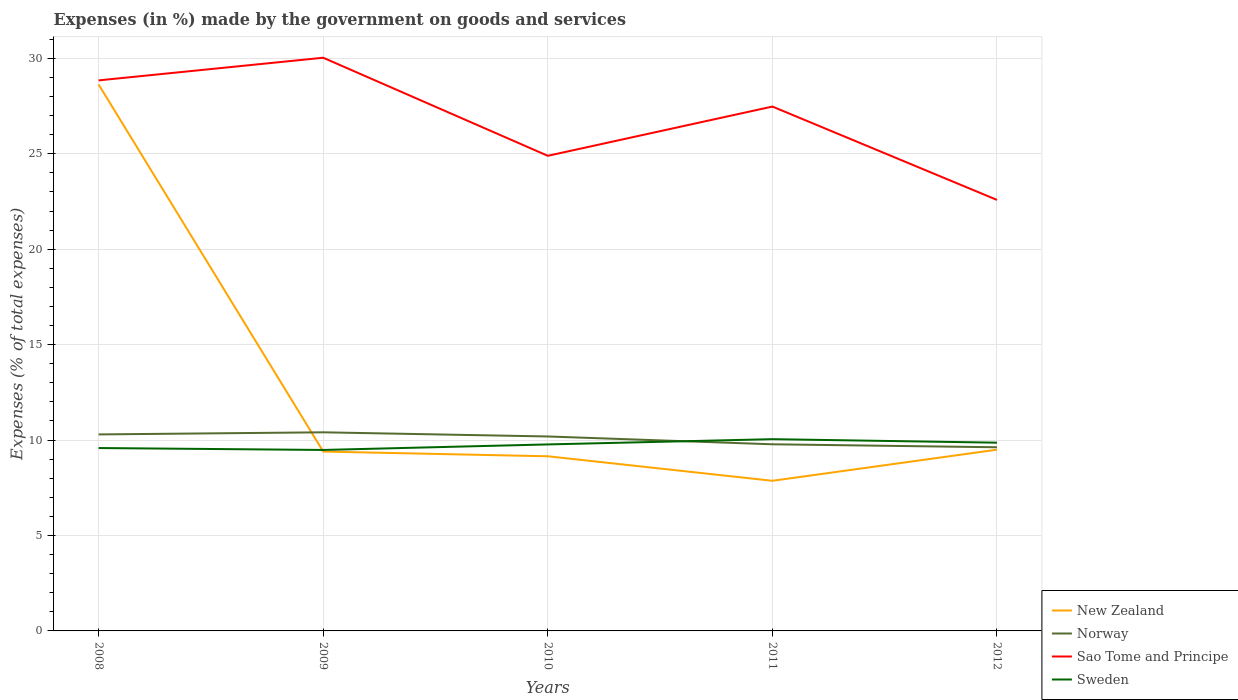Does the line corresponding to Norway intersect with the line corresponding to New Zealand?
Your answer should be very brief. Yes. Is the number of lines equal to the number of legend labels?
Your answer should be compact. Yes. Across all years, what is the maximum percentage of expenses made by the government on goods and services in Sweden?
Offer a terse response. 9.48. What is the total percentage of expenses made by the government on goods and services in New Zealand in the graph?
Offer a very short reply. 1.28. What is the difference between the highest and the second highest percentage of expenses made by the government on goods and services in Sweden?
Ensure brevity in your answer.  0.57. What is the difference between the highest and the lowest percentage of expenses made by the government on goods and services in Norway?
Make the answer very short. 3. How many lines are there?
Your answer should be compact. 4. Does the graph contain any zero values?
Provide a short and direct response. No. How many legend labels are there?
Provide a short and direct response. 4. What is the title of the graph?
Your answer should be very brief. Expenses (in %) made by the government on goods and services. Does "Tajikistan" appear as one of the legend labels in the graph?
Provide a short and direct response. No. What is the label or title of the Y-axis?
Your answer should be compact. Expenses (% of total expenses). What is the Expenses (% of total expenses) of New Zealand in 2008?
Your answer should be very brief. 28.63. What is the Expenses (% of total expenses) of Norway in 2008?
Provide a succinct answer. 10.3. What is the Expenses (% of total expenses) of Sao Tome and Principe in 2008?
Keep it short and to the point. 28.85. What is the Expenses (% of total expenses) in Sweden in 2008?
Offer a very short reply. 9.58. What is the Expenses (% of total expenses) of New Zealand in 2009?
Ensure brevity in your answer.  9.4. What is the Expenses (% of total expenses) of Norway in 2009?
Make the answer very short. 10.41. What is the Expenses (% of total expenses) in Sao Tome and Principe in 2009?
Your response must be concise. 30.03. What is the Expenses (% of total expenses) in Sweden in 2009?
Give a very brief answer. 9.48. What is the Expenses (% of total expenses) of New Zealand in 2010?
Provide a succinct answer. 9.15. What is the Expenses (% of total expenses) in Norway in 2010?
Provide a short and direct response. 10.19. What is the Expenses (% of total expenses) of Sao Tome and Principe in 2010?
Make the answer very short. 24.89. What is the Expenses (% of total expenses) in Sweden in 2010?
Offer a very short reply. 9.77. What is the Expenses (% of total expenses) of New Zealand in 2011?
Ensure brevity in your answer.  7.87. What is the Expenses (% of total expenses) of Norway in 2011?
Offer a terse response. 9.78. What is the Expenses (% of total expenses) in Sao Tome and Principe in 2011?
Offer a terse response. 27.47. What is the Expenses (% of total expenses) in Sweden in 2011?
Offer a very short reply. 10.05. What is the Expenses (% of total expenses) in New Zealand in 2012?
Offer a very short reply. 9.5. What is the Expenses (% of total expenses) in Norway in 2012?
Your answer should be very brief. 9.62. What is the Expenses (% of total expenses) in Sao Tome and Principe in 2012?
Make the answer very short. 22.58. What is the Expenses (% of total expenses) in Sweden in 2012?
Your response must be concise. 9.86. Across all years, what is the maximum Expenses (% of total expenses) in New Zealand?
Provide a succinct answer. 28.63. Across all years, what is the maximum Expenses (% of total expenses) of Norway?
Your answer should be very brief. 10.41. Across all years, what is the maximum Expenses (% of total expenses) in Sao Tome and Principe?
Ensure brevity in your answer.  30.03. Across all years, what is the maximum Expenses (% of total expenses) in Sweden?
Keep it short and to the point. 10.05. Across all years, what is the minimum Expenses (% of total expenses) of New Zealand?
Keep it short and to the point. 7.87. Across all years, what is the minimum Expenses (% of total expenses) of Norway?
Make the answer very short. 9.62. Across all years, what is the minimum Expenses (% of total expenses) in Sao Tome and Principe?
Give a very brief answer. 22.58. Across all years, what is the minimum Expenses (% of total expenses) of Sweden?
Your answer should be very brief. 9.48. What is the total Expenses (% of total expenses) in New Zealand in the graph?
Your answer should be compact. 64.54. What is the total Expenses (% of total expenses) in Norway in the graph?
Ensure brevity in your answer.  50.29. What is the total Expenses (% of total expenses) in Sao Tome and Principe in the graph?
Your answer should be compact. 133.83. What is the total Expenses (% of total expenses) in Sweden in the graph?
Provide a short and direct response. 48.75. What is the difference between the Expenses (% of total expenses) of New Zealand in 2008 and that in 2009?
Provide a short and direct response. 19.23. What is the difference between the Expenses (% of total expenses) in Norway in 2008 and that in 2009?
Keep it short and to the point. -0.11. What is the difference between the Expenses (% of total expenses) of Sao Tome and Principe in 2008 and that in 2009?
Offer a terse response. -1.19. What is the difference between the Expenses (% of total expenses) of Sweden in 2008 and that in 2009?
Give a very brief answer. 0.1. What is the difference between the Expenses (% of total expenses) in New Zealand in 2008 and that in 2010?
Your answer should be compact. 19.48. What is the difference between the Expenses (% of total expenses) in Norway in 2008 and that in 2010?
Give a very brief answer. 0.11. What is the difference between the Expenses (% of total expenses) in Sao Tome and Principe in 2008 and that in 2010?
Your answer should be compact. 3.95. What is the difference between the Expenses (% of total expenses) of Sweden in 2008 and that in 2010?
Your response must be concise. -0.19. What is the difference between the Expenses (% of total expenses) of New Zealand in 2008 and that in 2011?
Keep it short and to the point. 20.76. What is the difference between the Expenses (% of total expenses) in Norway in 2008 and that in 2011?
Ensure brevity in your answer.  0.52. What is the difference between the Expenses (% of total expenses) of Sao Tome and Principe in 2008 and that in 2011?
Ensure brevity in your answer.  1.37. What is the difference between the Expenses (% of total expenses) in Sweden in 2008 and that in 2011?
Your answer should be compact. -0.46. What is the difference between the Expenses (% of total expenses) in New Zealand in 2008 and that in 2012?
Keep it short and to the point. 19.13. What is the difference between the Expenses (% of total expenses) in Norway in 2008 and that in 2012?
Provide a short and direct response. 0.67. What is the difference between the Expenses (% of total expenses) in Sao Tome and Principe in 2008 and that in 2012?
Provide a succinct answer. 6.26. What is the difference between the Expenses (% of total expenses) of Sweden in 2008 and that in 2012?
Provide a short and direct response. -0.28. What is the difference between the Expenses (% of total expenses) of New Zealand in 2009 and that in 2010?
Offer a very short reply. 0.25. What is the difference between the Expenses (% of total expenses) of Norway in 2009 and that in 2010?
Ensure brevity in your answer.  0.22. What is the difference between the Expenses (% of total expenses) of Sao Tome and Principe in 2009 and that in 2010?
Give a very brief answer. 5.14. What is the difference between the Expenses (% of total expenses) of Sweden in 2009 and that in 2010?
Your answer should be very brief. -0.29. What is the difference between the Expenses (% of total expenses) of New Zealand in 2009 and that in 2011?
Offer a terse response. 1.53. What is the difference between the Expenses (% of total expenses) of Norway in 2009 and that in 2011?
Your answer should be compact. 0.63. What is the difference between the Expenses (% of total expenses) in Sao Tome and Principe in 2009 and that in 2011?
Your response must be concise. 2.56. What is the difference between the Expenses (% of total expenses) of Sweden in 2009 and that in 2011?
Ensure brevity in your answer.  -0.57. What is the difference between the Expenses (% of total expenses) in New Zealand in 2009 and that in 2012?
Give a very brief answer. -0.1. What is the difference between the Expenses (% of total expenses) of Norway in 2009 and that in 2012?
Keep it short and to the point. 0.78. What is the difference between the Expenses (% of total expenses) in Sao Tome and Principe in 2009 and that in 2012?
Keep it short and to the point. 7.45. What is the difference between the Expenses (% of total expenses) in Sweden in 2009 and that in 2012?
Offer a terse response. -0.38. What is the difference between the Expenses (% of total expenses) in New Zealand in 2010 and that in 2011?
Provide a succinct answer. 1.28. What is the difference between the Expenses (% of total expenses) of Norway in 2010 and that in 2011?
Make the answer very short. 0.41. What is the difference between the Expenses (% of total expenses) in Sao Tome and Principe in 2010 and that in 2011?
Your response must be concise. -2.58. What is the difference between the Expenses (% of total expenses) of Sweden in 2010 and that in 2011?
Provide a succinct answer. -0.28. What is the difference between the Expenses (% of total expenses) in New Zealand in 2010 and that in 2012?
Give a very brief answer. -0.35. What is the difference between the Expenses (% of total expenses) in Norway in 2010 and that in 2012?
Make the answer very short. 0.57. What is the difference between the Expenses (% of total expenses) of Sao Tome and Principe in 2010 and that in 2012?
Your response must be concise. 2.31. What is the difference between the Expenses (% of total expenses) of Sweden in 2010 and that in 2012?
Provide a short and direct response. -0.09. What is the difference between the Expenses (% of total expenses) of New Zealand in 2011 and that in 2012?
Provide a succinct answer. -1.63. What is the difference between the Expenses (% of total expenses) of Norway in 2011 and that in 2012?
Offer a very short reply. 0.16. What is the difference between the Expenses (% of total expenses) in Sao Tome and Principe in 2011 and that in 2012?
Ensure brevity in your answer.  4.89. What is the difference between the Expenses (% of total expenses) in Sweden in 2011 and that in 2012?
Your response must be concise. 0.18. What is the difference between the Expenses (% of total expenses) of New Zealand in 2008 and the Expenses (% of total expenses) of Norway in 2009?
Give a very brief answer. 18.22. What is the difference between the Expenses (% of total expenses) in New Zealand in 2008 and the Expenses (% of total expenses) in Sao Tome and Principe in 2009?
Offer a very short reply. -1.4. What is the difference between the Expenses (% of total expenses) in New Zealand in 2008 and the Expenses (% of total expenses) in Sweden in 2009?
Keep it short and to the point. 19.15. What is the difference between the Expenses (% of total expenses) of Norway in 2008 and the Expenses (% of total expenses) of Sao Tome and Principe in 2009?
Provide a short and direct response. -19.74. What is the difference between the Expenses (% of total expenses) of Norway in 2008 and the Expenses (% of total expenses) of Sweden in 2009?
Make the answer very short. 0.81. What is the difference between the Expenses (% of total expenses) of Sao Tome and Principe in 2008 and the Expenses (% of total expenses) of Sweden in 2009?
Your response must be concise. 19.36. What is the difference between the Expenses (% of total expenses) of New Zealand in 2008 and the Expenses (% of total expenses) of Norway in 2010?
Offer a terse response. 18.44. What is the difference between the Expenses (% of total expenses) of New Zealand in 2008 and the Expenses (% of total expenses) of Sao Tome and Principe in 2010?
Your answer should be very brief. 3.74. What is the difference between the Expenses (% of total expenses) in New Zealand in 2008 and the Expenses (% of total expenses) in Sweden in 2010?
Ensure brevity in your answer.  18.86. What is the difference between the Expenses (% of total expenses) of Norway in 2008 and the Expenses (% of total expenses) of Sao Tome and Principe in 2010?
Ensure brevity in your answer.  -14.6. What is the difference between the Expenses (% of total expenses) in Norway in 2008 and the Expenses (% of total expenses) in Sweden in 2010?
Make the answer very short. 0.52. What is the difference between the Expenses (% of total expenses) in Sao Tome and Principe in 2008 and the Expenses (% of total expenses) in Sweden in 2010?
Your answer should be compact. 19.07. What is the difference between the Expenses (% of total expenses) in New Zealand in 2008 and the Expenses (% of total expenses) in Norway in 2011?
Provide a short and direct response. 18.85. What is the difference between the Expenses (% of total expenses) in New Zealand in 2008 and the Expenses (% of total expenses) in Sao Tome and Principe in 2011?
Provide a short and direct response. 1.15. What is the difference between the Expenses (% of total expenses) in New Zealand in 2008 and the Expenses (% of total expenses) in Sweden in 2011?
Provide a short and direct response. 18.58. What is the difference between the Expenses (% of total expenses) of Norway in 2008 and the Expenses (% of total expenses) of Sao Tome and Principe in 2011?
Your response must be concise. -17.18. What is the difference between the Expenses (% of total expenses) in Norway in 2008 and the Expenses (% of total expenses) in Sweden in 2011?
Provide a short and direct response. 0.25. What is the difference between the Expenses (% of total expenses) of Sao Tome and Principe in 2008 and the Expenses (% of total expenses) of Sweden in 2011?
Provide a short and direct response. 18.8. What is the difference between the Expenses (% of total expenses) in New Zealand in 2008 and the Expenses (% of total expenses) in Norway in 2012?
Your response must be concise. 19.01. What is the difference between the Expenses (% of total expenses) of New Zealand in 2008 and the Expenses (% of total expenses) of Sao Tome and Principe in 2012?
Give a very brief answer. 6.05. What is the difference between the Expenses (% of total expenses) of New Zealand in 2008 and the Expenses (% of total expenses) of Sweden in 2012?
Provide a short and direct response. 18.77. What is the difference between the Expenses (% of total expenses) in Norway in 2008 and the Expenses (% of total expenses) in Sao Tome and Principe in 2012?
Provide a succinct answer. -12.29. What is the difference between the Expenses (% of total expenses) in Norway in 2008 and the Expenses (% of total expenses) in Sweden in 2012?
Offer a very short reply. 0.43. What is the difference between the Expenses (% of total expenses) of Sao Tome and Principe in 2008 and the Expenses (% of total expenses) of Sweden in 2012?
Offer a very short reply. 18.98. What is the difference between the Expenses (% of total expenses) in New Zealand in 2009 and the Expenses (% of total expenses) in Norway in 2010?
Make the answer very short. -0.79. What is the difference between the Expenses (% of total expenses) in New Zealand in 2009 and the Expenses (% of total expenses) in Sao Tome and Principe in 2010?
Ensure brevity in your answer.  -15.5. What is the difference between the Expenses (% of total expenses) in New Zealand in 2009 and the Expenses (% of total expenses) in Sweden in 2010?
Offer a very short reply. -0.37. What is the difference between the Expenses (% of total expenses) of Norway in 2009 and the Expenses (% of total expenses) of Sao Tome and Principe in 2010?
Give a very brief answer. -14.49. What is the difference between the Expenses (% of total expenses) of Norway in 2009 and the Expenses (% of total expenses) of Sweden in 2010?
Give a very brief answer. 0.63. What is the difference between the Expenses (% of total expenses) of Sao Tome and Principe in 2009 and the Expenses (% of total expenses) of Sweden in 2010?
Offer a very short reply. 20.26. What is the difference between the Expenses (% of total expenses) of New Zealand in 2009 and the Expenses (% of total expenses) of Norway in 2011?
Make the answer very short. -0.38. What is the difference between the Expenses (% of total expenses) in New Zealand in 2009 and the Expenses (% of total expenses) in Sao Tome and Principe in 2011?
Give a very brief answer. -18.08. What is the difference between the Expenses (% of total expenses) in New Zealand in 2009 and the Expenses (% of total expenses) in Sweden in 2011?
Your response must be concise. -0.65. What is the difference between the Expenses (% of total expenses) of Norway in 2009 and the Expenses (% of total expenses) of Sao Tome and Principe in 2011?
Make the answer very short. -17.07. What is the difference between the Expenses (% of total expenses) in Norway in 2009 and the Expenses (% of total expenses) in Sweden in 2011?
Keep it short and to the point. 0.36. What is the difference between the Expenses (% of total expenses) of Sao Tome and Principe in 2009 and the Expenses (% of total expenses) of Sweden in 2011?
Keep it short and to the point. 19.99. What is the difference between the Expenses (% of total expenses) in New Zealand in 2009 and the Expenses (% of total expenses) in Norway in 2012?
Give a very brief answer. -0.22. What is the difference between the Expenses (% of total expenses) in New Zealand in 2009 and the Expenses (% of total expenses) in Sao Tome and Principe in 2012?
Your response must be concise. -13.18. What is the difference between the Expenses (% of total expenses) in New Zealand in 2009 and the Expenses (% of total expenses) in Sweden in 2012?
Offer a terse response. -0.47. What is the difference between the Expenses (% of total expenses) in Norway in 2009 and the Expenses (% of total expenses) in Sao Tome and Principe in 2012?
Offer a terse response. -12.18. What is the difference between the Expenses (% of total expenses) of Norway in 2009 and the Expenses (% of total expenses) of Sweden in 2012?
Offer a terse response. 0.54. What is the difference between the Expenses (% of total expenses) in Sao Tome and Principe in 2009 and the Expenses (% of total expenses) in Sweden in 2012?
Your answer should be very brief. 20.17. What is the difference between the Expenses (% of total expenses) of New Zealand in 2010 and the Expenses (% of total expenses) of Norway in 2011?
Your answer should be very brief. -0.63. What is the difference between the Expenses (% of total expenses) in New Zealand in 2010 and the Expenses (% of total expenses) in Sao Tome and Principe in 2011?
Give a very brief answer. -18.32. What is the difference between the Expenses (% of total expenses) in New Zealand in 2010 and the Expenses (% of total expenses) in Sweden in 2011?
Make the answer very short. -0.9. What is the difference between the Expenses (% of total expenses) in Norway in 2010 and the Expenses (% of total expenses) in Sao Tome and Principe in 2011?
Give a very brief answer. -17.29. What is the difference between the Expenses (% of total expenses) in Norway in 2010 and the Expenses (% of total expenses) in Sweden in 2011?
Provide a succinct answer. 0.14. What is the difference between the Expenses (% of total expenses) of Sao Tome and Principe in 2010 and the Expenses (% of total expenses) of Sweden in 2011?
Provide a short and direct response. 14.85. What is the difference between the Expenses (% of total expenses) of New Zealand in 2010 and the Expenses (% of total expenses) of Norway in 2012?
Make the answer very short. -0.47. What is the difference between the Expenses (% of total expenses) of New Zealand in 2010 and the Expenses (% of total expenses) of Sao Tome and Principe in 2012?
Keep it short and to the point. -13.43. What is the difference between the Expenses (% of total expenses) of New Zealand in 2010 and the Expenses (% of total expenses) of Sweden in 2012?
Keep it short and to the point. -0.71. What is the difference between the Expenses (% of total expenses) of Norway in 2010 and the Expenses (% of total expenses) of Sao Tome and Principe in 2012?
Offer a very short reply. -12.39. What is the difference between the Expenses (% of total expenses) of Norway in 2010 and the Expenses (% of total expenses) of Sweden in 2012?
Provide a succinct answer. 0.33. What is the difference between the Expenses (% of total expenses) in Sao Tome and Principe in 2010 and the Expenses (% of total expenses) in Sweden in 2012?
Your answer should be very brief. 15.03. What is the difference between the Expenses (% of total expenses) of New Zealand in 2011 and the Expenses (% of total expenses) of Norway in 2012?
Offer a terse response. -1.76. What is the difference between the Expenses (% of total expenses) in New Zealand in 2011 and the Expenses (% of total expenses) in Sao Tome and Principe in 2012?
Make the answer very short. -14.72. What is the difference between the Expenses (% of total expenses) of New Zealand in 2011 and the Expenses (% of total expenses) of Sweden in 2012?
Your answer should be very brief. -2. What is the difference between the Expenses (% of total expenses) in Norway in 2011 and the Expenses (% of total expenses) in Sao Tome and Principe in 2012?
Provide a succinct answer. -12.8. What is the difference between the Expenses (% of total expenses) in Norway in 2011 and the Expenses (% of total expenses) in Sweden in 2012?
Your answer should be very brief. -0.08. What is the difference between the Expenses (% of total expenses) of Sao Tome and Principe in 2011 and the Expenses (% of total expenses) of Sweden in 2012?
Your response must be concise. 17.61. What is the average Expenses (% of total expenses) of New Zealand per year?
Your answer should be compact. 12.91. What is the average Expenses (% of total expenses) in Norway per year?
Your answer should be very brief. 10.06. What is the average Expenses (% of total expenses) in Sao Tome and Principe per year?
Make the answer very short. 26.77. What is the average Expenses (% of total expenses) in Sweden per year?
Your answer should be compact. 9.75. In the year 2008, what is the difference between the Expenses (% of total expenses) of New Zealand and Expenses (% of total expenses) of Norway?
Provide a succinct answer. 18.33. In the year 2008, what is the difference between the Expenses (% of total expenses) of New Zealand and Expenses (% of total expenses) of Sao Tome and Principe?
Offer a terse response. -0.22. In the year 2008, what is the difference between the Expenses (% of total expenses) of New Zealand and Expenses (% of total expenses) of Sweden?
Your response must be concise. 19.05. In the year 2008, what is the difference between the Expenses (% of total expenses) of Norway and Expenses (% of total expenses) of Sao Tome and Principe?
Offer a terse response. -18.55. In the year 2008, what is the difference between the Expenses (% of total expenses) of Norway and Expenses (% of total expenses) of Sweden?
Keep it short and to the point. 0.71. In the year 2008, what is the difference between the Expenses (% of total expenses) of Sao Tome and Principe and Expenses (% of total expenses) of Sweden?
Provide a succinct answer. 19.26. In the year 2009, what is the difference between the Expenses (% of total expenses) of New Zealand and Expenses (% of total expenses) of Norway?
Offer a terse response. -1.01. In the year 2009, what is the difference between the Expenses (% of total expenses) in New Zealand and Expenses (% of total expenses) in Sao Tome and Principe?
Keep it short and to the point. -20.63. In the year 2009, what is the difference between the Expenses (% of total expenses) of New Zealand and Expenses (% of total expenses) of Sweden?
Keep it short and to the point. -0.08. In the year 2009, what is the difference between the Expenses (% of total expenses) in Norway and Expenses (% of total expenses) in Sao Tome and Principe?
Your response must be concise. -19.63. In the year 2009, what is the difference between the Expenses (% of total expenses) in Norway and Expenses (% of total expenses) in Sweden?
Provide a short and direct response. 0.92. In the year 2009, what is the difference between the Expenses (% of total expenses) in Sao Tome and Principe and Expenses (% of total expenses) in Sweden?
Your answer should be very brief. 20.55. In the year 2010, what is the difference between the Expenses (% of total expenses) of New Zealand and Expenses (% of total expenses) of Norway?
Ensure brevity in your answer.  -1.04. In the year 2010, what is the difference between the Expenses (% of total expenses) of New Zealand and Expenses (% of total expenses) of Sao Tome and Principe?
Your answer should be very brief. -15.74. In the year 2010, what is the difference between the Expenses (% of total expenses) in New Zealand and Expenses (% of total expenses) in Sweden?
Offer a very short reply. -0.62. In the year 2010, what is the difference between the Expenses (% of total expenses) of Norway and Expenses (% of total expenses) of Sao Tome and Principe?
Keep it short and to the point. -14.71. In the year 2010, what is the difference between the Expenses (% of total expenses) in Norway and Expenses (% of total expenses) in Sweden?
Ensure brevity in your answer.  0.42. In the year 2010, what is the difference between the Expenses (% of total expenses) in Sao Tome and Principe and Expenses (% of total expenses) in Sweden?
Keep it short and to the point. 15.12. In the year 2011, what is the difference between the Expenses (% of total expenses) of New Zealand and Expenses (% of total expenses) of Norway?
Provide a succinct answer. -1.91. In the year 2011, what is the difference between the Expenses (% of total expenses) in New Zealand and Expenses (% of total expenses) in Sao Tome and Principe?
Make the answer very short. -19.61. In the year 2011, what is the difference between the Expenses (% of total expenses) of New Zealand and Expenses (% of total expenses) of Sweden?
Offer a terse response. -2.18. In the year 2011, what is the difference between the Expenses (% of total expenses) in Norway and Expenses (% of total expenses) in Sao Tome and Principe?
Offer a terse response. -17.7. In the year 2011, what is the difference between the Expenses (% of total expenses) of Norway and Expenses (% of total expenses) of Sweden?
Your answer should be compact. -0.27. In the year 2011, what is the difference between the Expenses (% of total expenses) of Sao Tome and Principe and Expenses (% of total expenses) of Sweden?
Your answer should be compact. 17.43. In the year 2012, what is the difference between the Expenses (% of total expenses) in New Zealand and Expenses (% of total expenses) in Norway?
Provide a succinct answer. -0.13. In the year 2012, what is the difference between the Expenses (% of total expenses) of New Zealand and Expenses (% of total expenses) of Sao Tome and Principe?
Make the answer very short. -13.09. In the year 2012, what is the difference between the Expenses (% of total expenses) of New Zealand and Expenses (% of total expenses) of Sweden?
Provide a short and direct response. -0.37. In the year 2012, what is the difference between the Expenses (% of total expenses) of Norway and Expenses (% of total expenses) of Sao Tome and Principe?
Offer a terse response. -12.96. In the year 2012, what is the difference between the Expenses (% of total expenses) of Norway and Expenses (% of total expenses) of Sweden?
Offer a terse response. -0.24. In the year 2012, what is the difference between the Expenses (% of total expenses) in Sao Tome and Principe and Expenses (% of total expenses) in Sweden?
Your response must be concise. 12.72. What is the ratio of the Expenses (% of total expenses) in New Zealand in 2008 to that in 2009?
Offer a very short reply. 3.05. What is the ratio of the Expenses (% of total expenses) in Norway in 2008 to that in 2009?
Offer a very short reply. 0.99. What is the ratio of the Expenses (% of total expenses) in Sao Tome and Principe in 2008 to that in 2009?
Offer a very short reply. 0.96. What is the ratio of the Expenses (% of total expenses) of Sweden in 2008 to that in 2009?
Your answer should be very brief. 1.01. What is the ratio of the Expenses (% of total expenses) in New Zealand in 2008 to that in 2010?
Ensure brevity in your answer.  3.13. What is the ratio of the Expenses (% of total expenses) of Norway in 2008 to that in 2010?
Offer a terse response. 1.01. What is the ratio of the Expenses (% of total expenses) of Sao Tome and Principe in 2008 to that in 2010?
Your response must be concise. 1.16. What is the ratio of the Expenses (% of total expenses) in Sweden in 2008 to that in 2010?
Offer a very short reply. 0.98. What is the ratio of the Expenses (% of total expenses) in New Zealand in 2008 to that in 2011?
Your answer should be very brief. 3.64. What is the ratio of the Expenses (% of total expenses) of Norway in 2008 to that in 2011?
Offer a very short reply. 1.05. What is the ratio of the Expenses (% of total expenses) of Sao Tome and Principe in 2008 to that in 2011?
Offer a terse response. 1.05. What is the ratio of the Expenses (% of total expenses) in Sweden in 2008 to that in 2011?
Your answer should be compact. 0.95. What is the ratio of the Expenses (% of total expenses) in New Zealand in 2008 to that in 2012?
Your response must be concise. 3.01. What is the ratio of the Expenses (% of total expenses) of Norway in 2008 to that in 2012?
Offer a very short reply. 1.07. What is the ratio of the Expenses (% of total expenses) in Sao Tome and Principe in 2008 to that in 2012?
Your answer should be very brief. 1.28. What is the ratio of the Expenses (% of total expenses) of Sweden in 2008 to that in 2012?
Provide a succinct answer. 0.97. What is the ratio of the Expenses (% of total expenses) in New Zealand in 2009 to that in 2010?
Give a very brief answer. 1.03. What is the ratio of the Expenses (% of total expenses) in Norway in 2009 to that in 2010?
Offer a very short reply. 1.02. What is the ratio of the Expenses (% of total expenses) in Sao Tome and Principe in 2009 to that in 2010?
Provide a succinct answer. 1.21. What is the ratio of the Expenses (% of total expenses) of Sweden in 2009 to that in 2010?
Give a very brief answer. 0.97. What is the ratio of the Expenses (% of total expenses) in New Zealand in 2009 to that in 2011?
Provide a short and direct response. 1.19. What is the ratio of the Expenses (% of total expenses) in Norway in 2009 to that in 2011?
Offer a terse response. 1.06. What is the ratio of the Expenses (% of total expenses) in Sao Tome and Principe in 2009 to that in 2011?
Ensure brevity in your answer.  1.09. What is the ratio of the Expenses (% of total expenses) in Sweden in 2009 to that in 2011?
Make the answer very short. 0.94. What is the ratio of the Expenses (% of total expenses) of New Zealand in 2009 to that in 2012?
Ensure brevity in your answer.  0.99. What is the ratio of the Expenses (% of total expenses) in Norway in 2009 to that in 2012?
Provide a succinct answer. 1.08. What is the ratio of the Expenses (% of total expenses) of Sao Tome and Principe in 2009 to that in 2012?
Provide a succinct answer. 1.33. What is the ratio of the Expenses (% of total expenses) of Sweden in 2009 to that in 2012?
Your answer should be very brief. 0.96. What is the ratio of the Expenses (% of total expenses) in New Zealand in 2010 to that in 2011?
Keep it short and to the point. 1.16. What is the ratio of the Expenses (% of total expenses) in Norway in 2010 to that in 2011?
Provide a short and direct response. 1.04. What is the ratio of the Expenses (% of total expenses) in Sao Tome and Principe in 2010 to that in 2011?
Keep it short and to the point. 0.91. What is the ratio of the Expenses (% of total expenses) in Sweden in 2010 to that in 2011?
Your answer should be very brief. 0.97. What is the ratio of the Expenses (% of total expenses) in New Zealand in 2010 to that in 2012?
Your answer should be very brief. 0.96. What is the ratio of the Expenses (% of total expenses) of Norway in 2010 to that in 2012?
Give a very brief answer. 1.06. What is the ratio of the Expenses (% of total expenses) in Sao Tome and Principe in 2010 to that in 2012?
Offer a terse response. 1.1. What is the ratio of the Expenses (% of total expenses) of Sweden in 2010 to that in 2012?
Ensure brevity in your answer.  0.99. What is the ratio of the Expenses (% of total expenses) of New Zealand in 2011 to that in 2012?
Make the answer very short. 0.83. What is the ratio of the Expenses (% of total expenses) of Norway in 2011 to that in 2012?
Your answer should be very brief. 1.02. What is the ratio of the Expenses (% of total expenses) in Sao Tome and Principe in 2011 to that in 2012?
Provide a short and direct response. 1.22. What is the ratio of the Expenses (% of total expenses) of Sweden in 2011 to that in 2012?
Offer a very short reply. 1.02. What is the difference between the highest and the second highest Expenses (% of total expenses) of New Zealand?
Your answer should be compact. 19.13. What is the difference between the highest and the second highest Expenses (% of total expenses) in Norway?
Your response must be concise. 0.11. What is the difference between the highest and the second highest Expenses (% of total expenses) of Sao Tome and Principe?
Provide a short and direct response. 1.19. What is the difference between the highest and the second highest Expenses (% of total expenses) of Sweden?
Your response must be concise. 0.18. What is the difference between the highest and the lowest Expenses (% of total expenses) in New Zealand?
Offer a very short reply. 20.76. What is the difference between the highest and the lowest Expenses (% of total expenses) in Norway?
Ensure brevity in your answer.  0.78. What is the difference between the highest and the lowest Expenses (% of total expenses) of Sao Tome and Principe?
Provide a succinct answer. 7.45. What is the difference between the highest and the lowest Expenses (% of total expenses) of Sweden?
Your response must be concise. 0.57. 